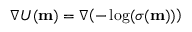Convert formula to latex. <formula><loc_0><loc_0><loc_500><loc_500>\nabla U ( m ) = \nabla \, \left ( - \log ( \sigma ( m ) ) \right )</formula> 